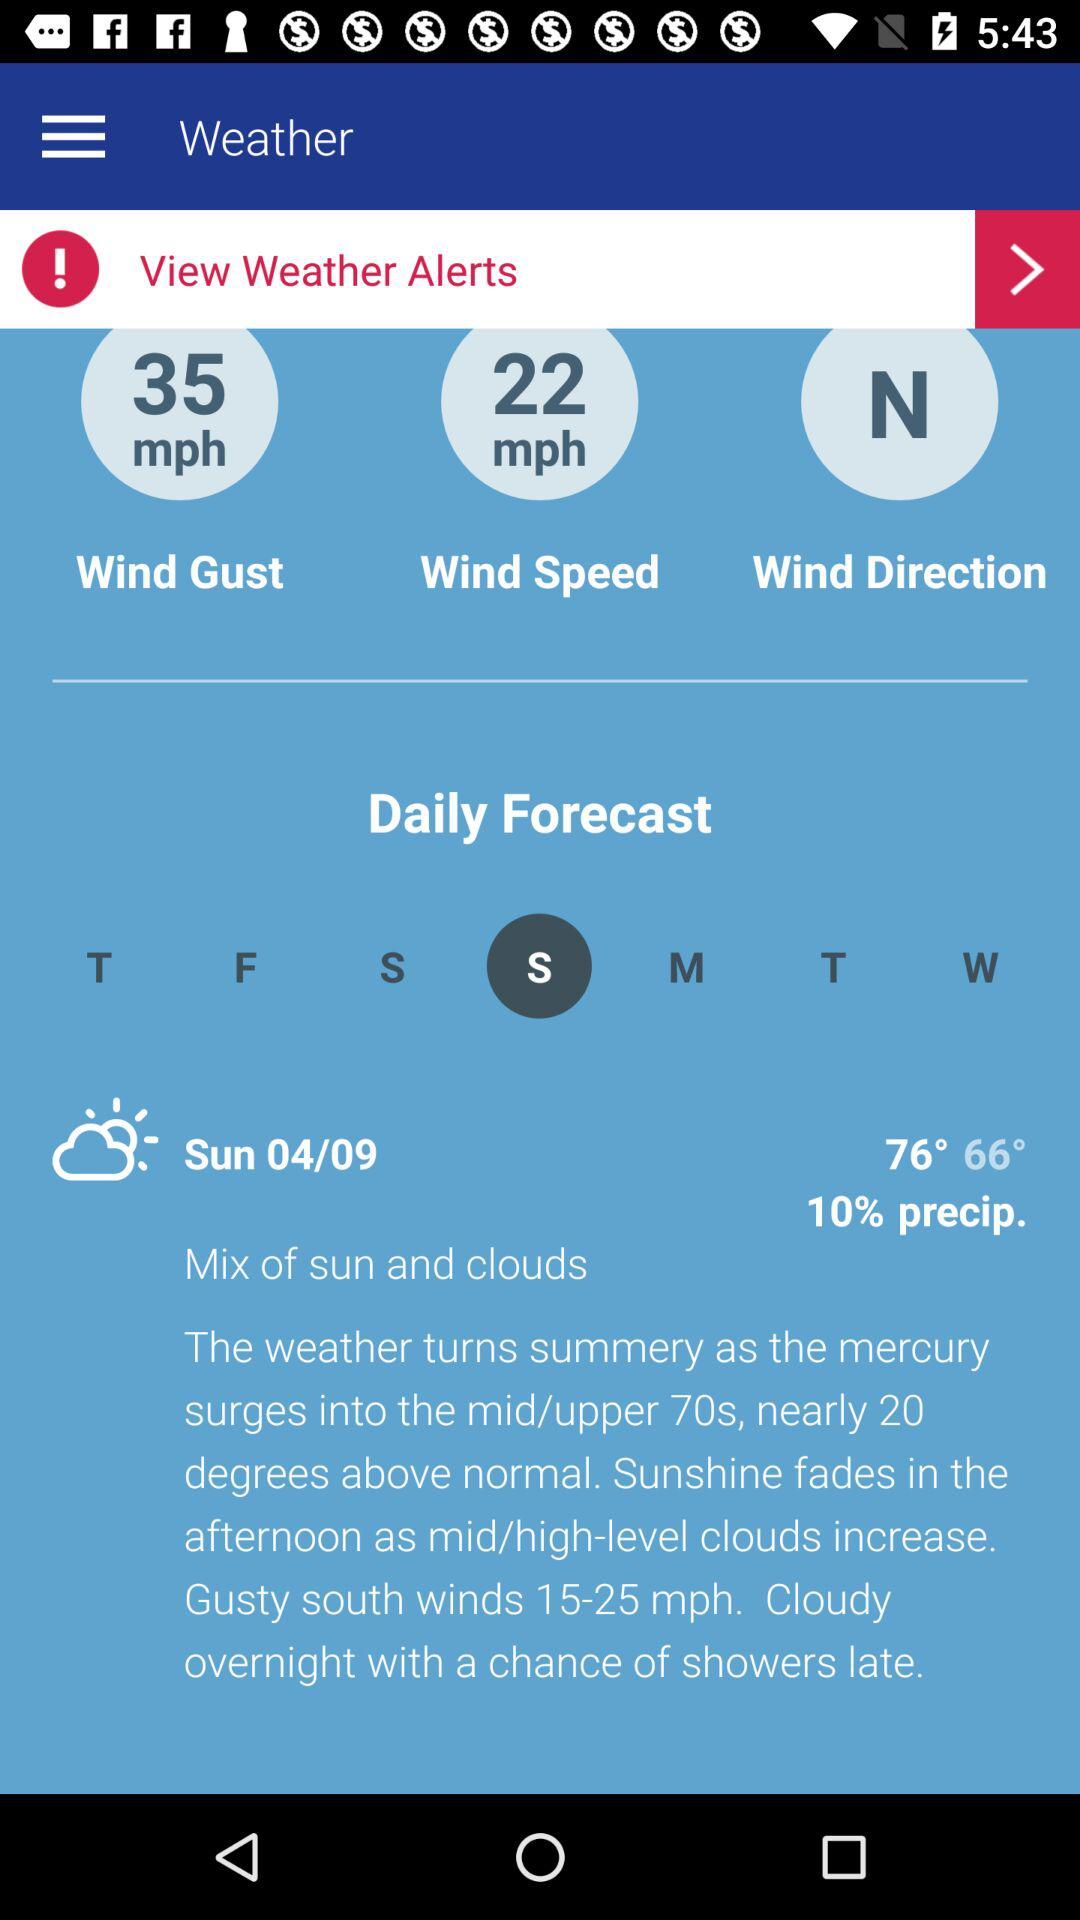What is the speed of wind gust? The speed is 35 mph. 